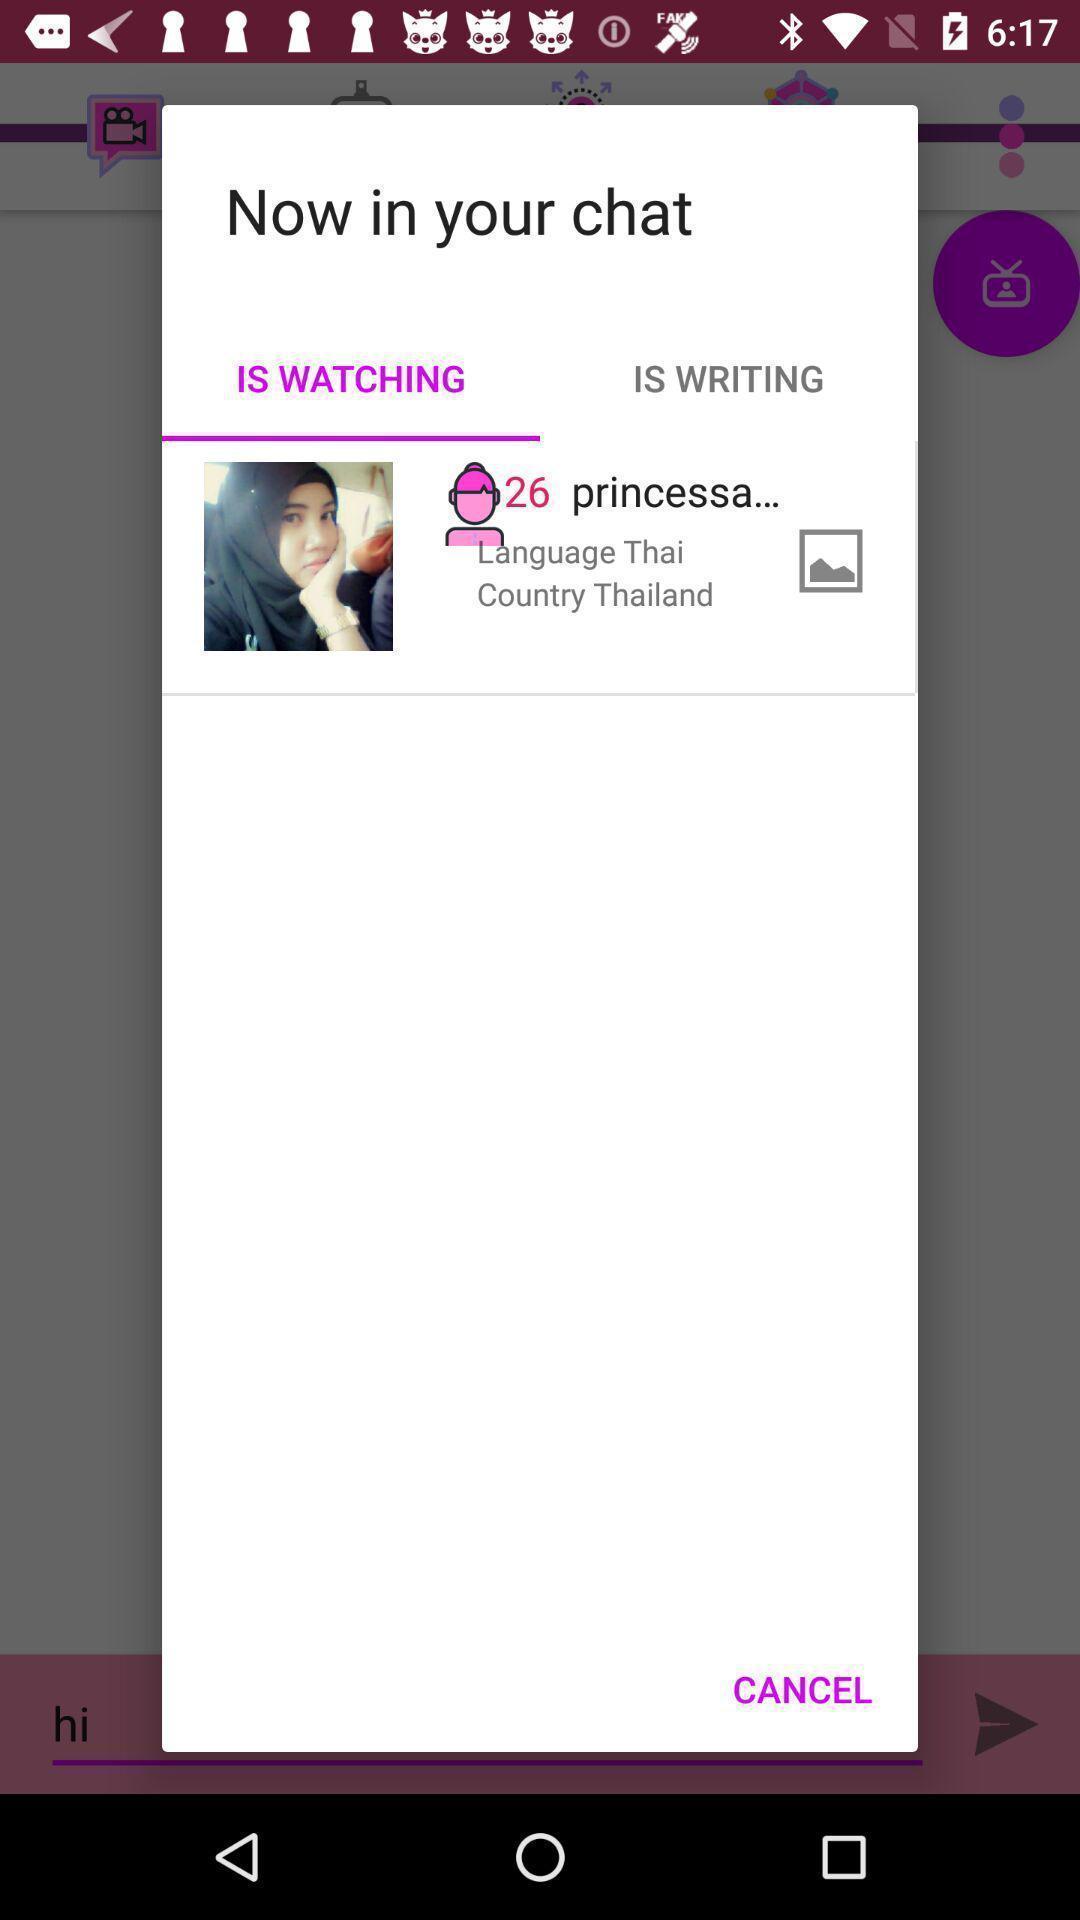Summarize the main components in this picture. Pop up showing watching story. 